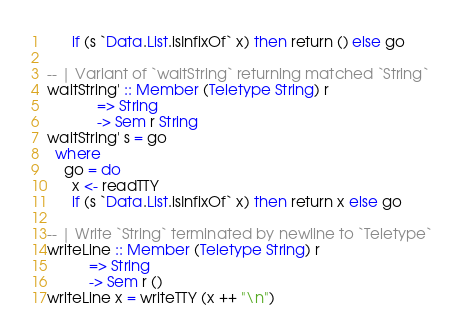<code> <loc_0><loc_0><loc_500><loc_500><_Haskell_>      if (s `Data.List.isInfixOf` x) then return () else go

-- | Variant of `waitString` returning matched `String`
waitString' :: Member (Teletype String) r
            => String
            -> Sem r String
waitString' s = go
  where
    go = do
      x <- readTTY
      if (s `Data.List.isInfixOf` x) then return x else go

-- | Write `String` terminated by newline to `Teletype`
writeLine :: Member (Teletype String) r
          => String
          -> Sem r ()
writeLine x = writeTTY (x ++ "\n")
</code> 